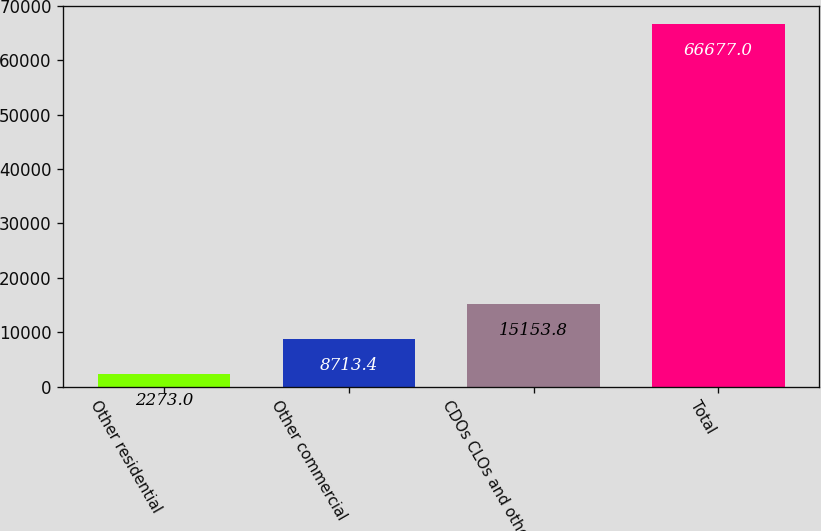Convert chart. <chart><loc_0><loc_0><loc_500><loc_500><bar_chart><fcel>Other residential<fcel>Other commercial<fcel>CDOs CLOs and other<fcel>Total<nl><fcel>2273<fcel>8713.4<fcel>15153.8<fcel>66677<nl></chart> 